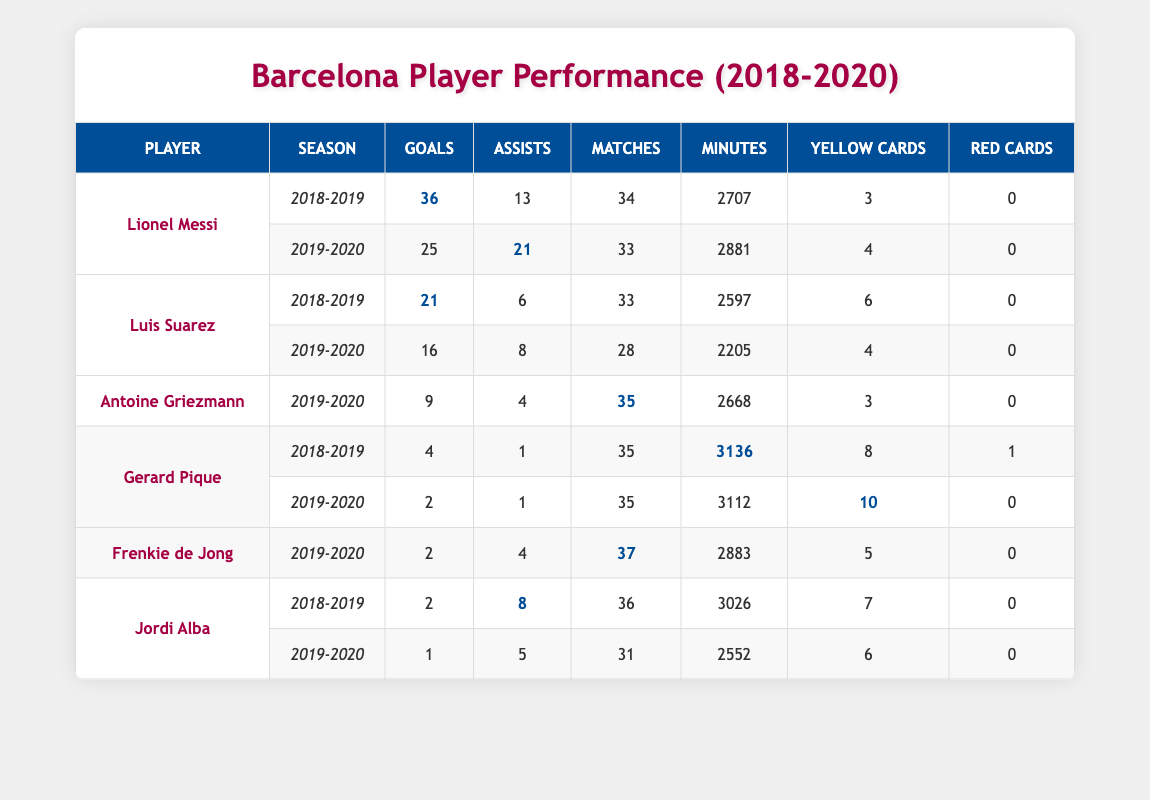What was Lionel Messi's highest number of goals in a single season? According to the table, Lionel Messi scored 36 goals during the 2018-2019 season, which is the highest figure listed for him across the two seasons shown.
Answer: 36 Which player had the most assists in the 2019-2020 season? In the 2019-2020 season, Lionel Messi led with 21 assists, as indicated in the table under the relevant statistics for that season.
Answer: 21 Did Luis Suarez receive more yellow cards in the 2018-2019 season compared to the 2019-2020 season? Looking at the table, Luis Suarez received 6 yellow cards in the 2018-2019 season and 4 in the 2019-2020 season, confirming he had more in the former season.
Answer: Yes What is the total number of goals scored by Gerard Pique over both seasons listed? To find Gerard Pique's total goals, we add his goals from the two seasons together: 4 (2018-2019) + 2 (2019-2020) = 6 goals in total.
Answer: 6 Was Antoine Griezmann's performance better in terms of assists compared to Luis Suarez in the 2019-2020 season? In the 2019-2020 season, Antoine Griezmann had 4 assists while Luis Suarez had 8 assists, indicating Griezmann performed worse in assists than Suarez.
Answer: No What is the average number of yellow cards received by players per season? By summing the yellow cards (3 + 4 + 6 + 4 + 3 + 8 + 10 + 5 + 7 + 6) which equal 56 cards over 10 instances, we find the average is 56 divided by 10, equaling 5.6.
Answer: 5.6 Who played more matches, Lionel Messi or Luis Suarez, in the 2018-2019 season? Lionel Messi played 34 matches, while Luis Suarez played 33 matches in the 2018-2019 season. Thus, Messi played more matches than Suarez that season.
Answer: Messi What was the total minutes played by Jordi Alba across both seasons? By adding Jordi Alba's minutes: 3026 (2018-2019) + 2552 (2019-2020), we get a total of 5578 minutes played across both seasons.
Answer: 5578 Did any player earn a red card during the 2018-2019 season? According to the table data, only Gerard Pique received a red card in the 2018-2019 season, confirming that he was the only player with a red card that season.
Answer: Yes 